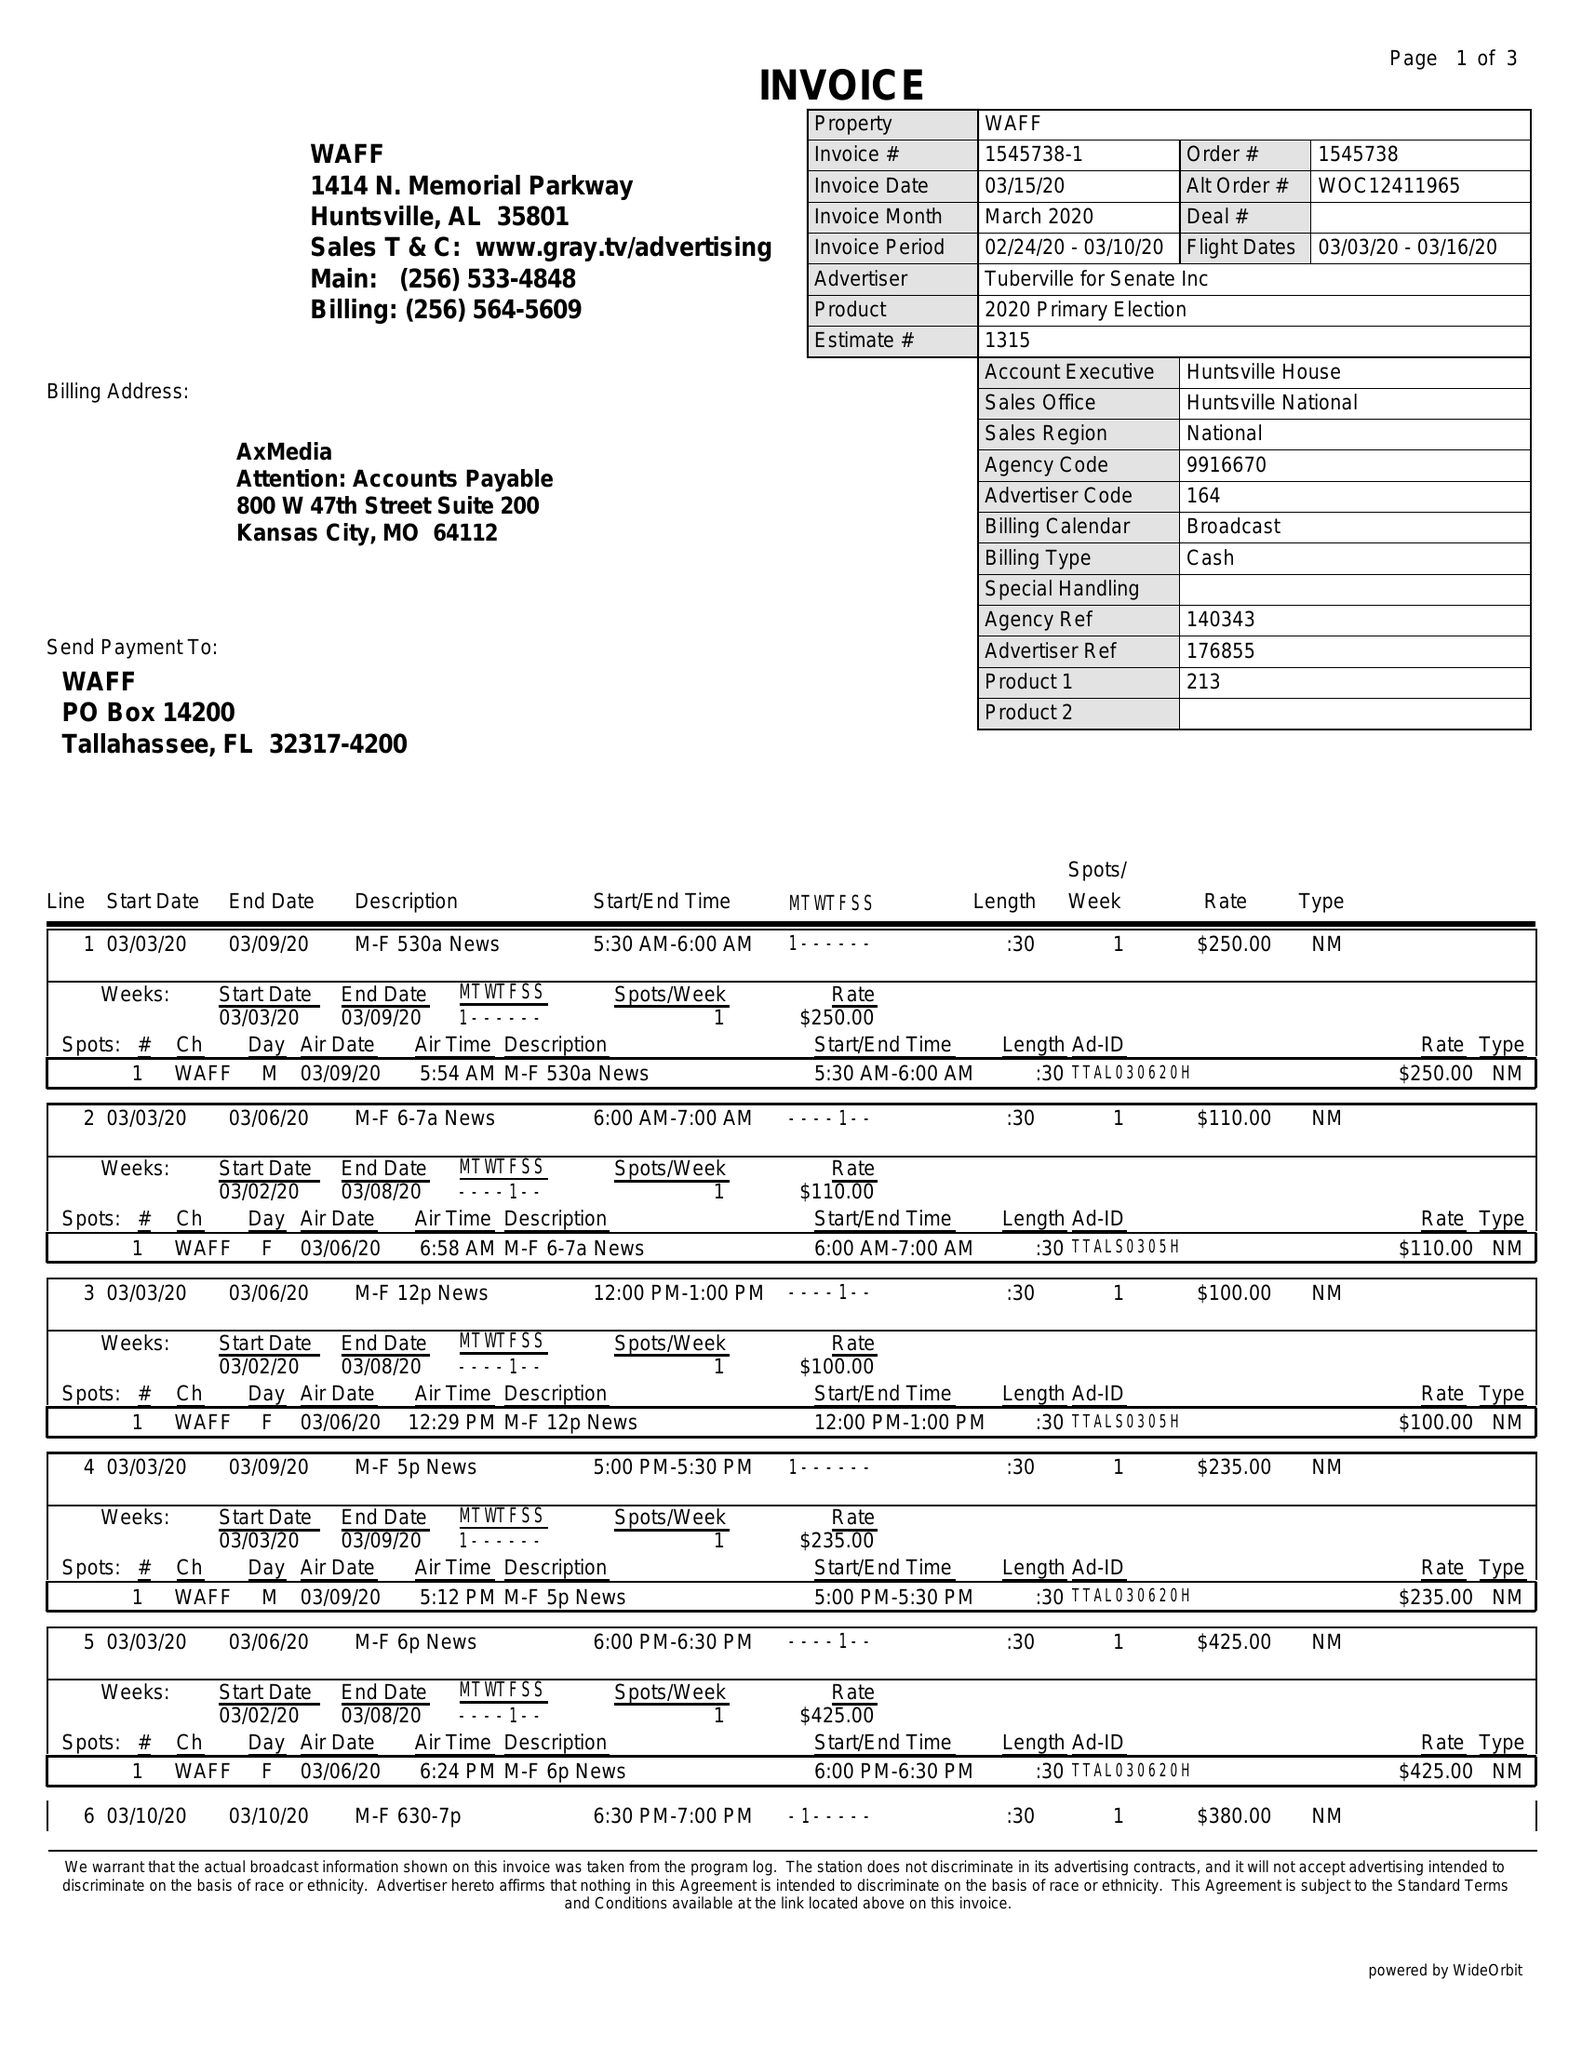What is the value for the advertiser?
Answer the question using a single word or phrase. TUBERVILLE FOR SENATE INC 